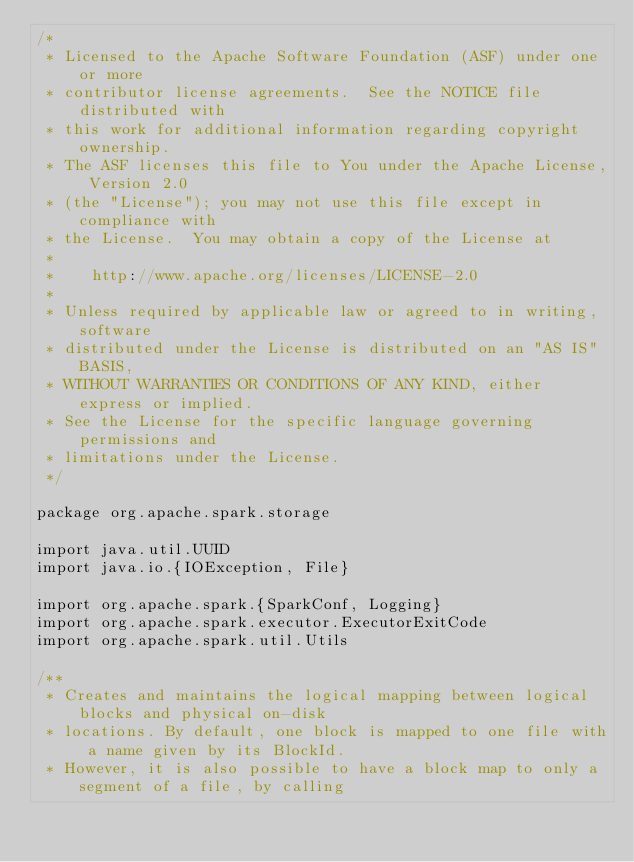<code> <loc_0><loc_0><loc_500><loc_500><_Scala_>/*
 * Licensed to the Apache Software Foundation (ASF) under one or more
 * contributor license agreements.  See the NOTICE file distributed with
 * this work for additional information regarding copyright ownership.
 * The ASF licenses this file to You under the Apache License, Version 2.0
 * (the "License"); you may not use this file except in compliance with
 * the License.  You may obtain a copy of the License at
 *
 *    http://www.apache.org/licenses/LICENSE-2.0
 *
 * Unless required by applicable law or agreed to in writing, software
 * distributed under the License is distributed on an "AS IS" BASIS,
 * WITHOUT WARRANTIES OR CONDITIONS OF ANY KIND, either express or implied.
 * See the License for the specific language governing permissions and
 * limitations under the License.
 */

package org.apache.spark.storage

import java.util.UUID
import java.io.{IOException, File}

import org.apache.spark.{SparkConf, Logging}
import org.apache.spark.executor.ExecutorExitCode
import org.apache.spark.util.Utils

/**
 * Creates and maintains the logical mapping between logical blocks and physical on-disk
 * locations. By default, one block is mapped to one file with a name given by its BlockId.
 * However, it is also possible to have a block map to only a segment of a file, by calling</code> 